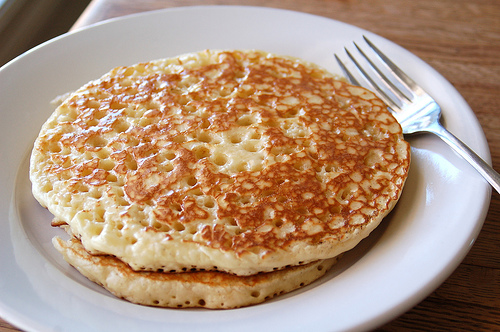<image>
Is there a pancake next to the fork? Yes. The pancake is positioned adjacent to the fork, located nearby in the same general area. 